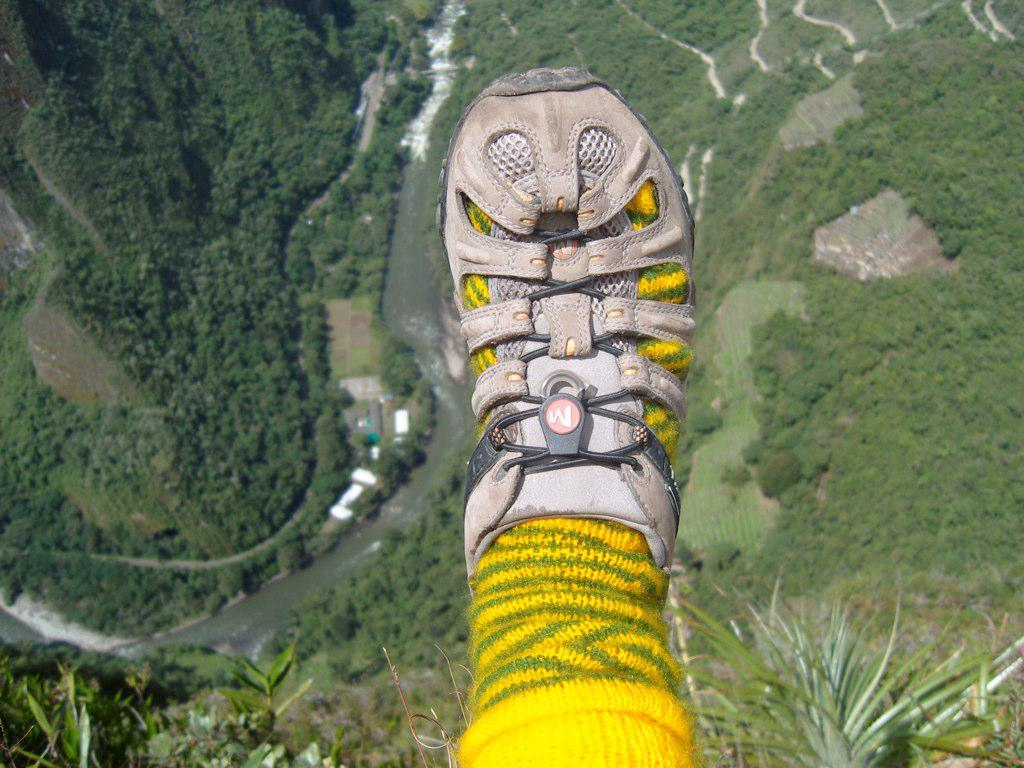Who is present in the image? There is a man in the image. What is the man doing in the image? The man is showing his shoes. What can be seen in the background of the image? The background of the image resembles a jungle scenery. What type of collar can be seen on the pizzas in the image? There are no pizzas present in the image, and therefore no collars can be seen on them. 